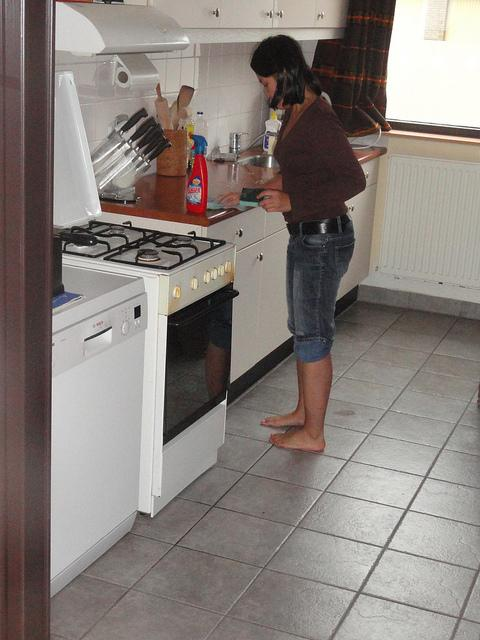What is the person doing in the kitchen? cleaning 